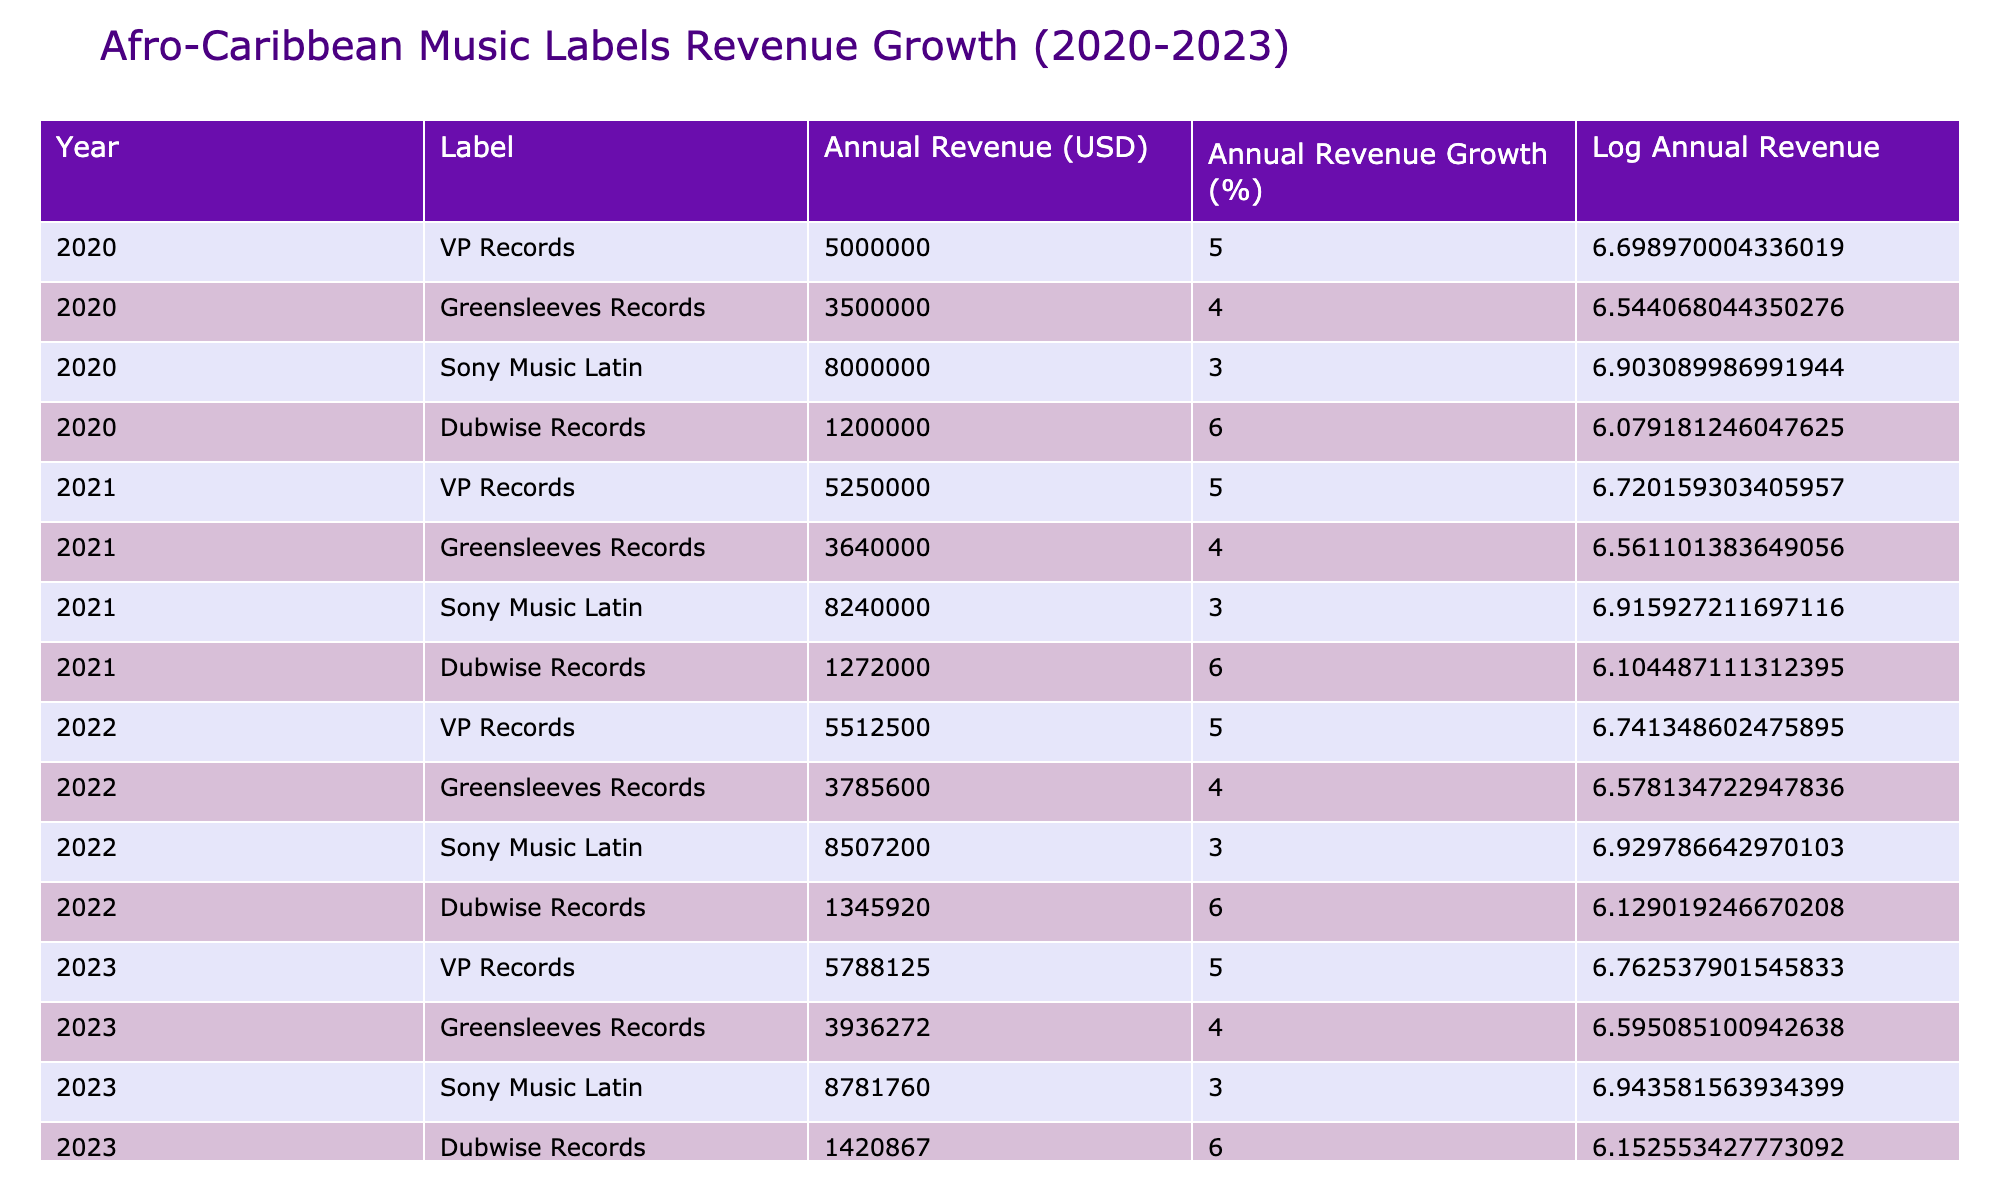What was the annual revenue of Sony Music Latin in 2022? From the table, the annual revenue for Sony Music Latin in 2022 is listed directly under the "Annual Revenue (USD)" column for the year 2022. It shows $8,507,200.
Answer: 8,507,200 Which Afro-Caribbean music label had the highest annual revenue in 2023? By looking at the table for the year 2023, the "Annual Revenue (USD)" values show that Sony Music Latin has the highest revenue of $8,781,760 among the listed labels.
Answer: Sony Music Latin What is the total annual revenue of Dubwise Records from 2020 to 2023? To find the total, we sum the annual revenues for Dubwise Records across all years: 1,200,000 (2020) + 1,272,000 (2021) + 1,345,920 (2022) + 1,420,867 (2023) = $5,238,787.
Answer: 5,238,787 Is the annual revenue growth for Greensleeves Records constant from 2020 to 2023? The table indicates that Greensleeves Records had an annual revenue growth of 4% for each year listed (2020 to 2023). Therefore, the growth is constant.
Answer: Yes Which label had the most significant annual revenue growth percentage in 2021 compared to 2020? The comparison of the growth percentages from 2020 to 2021 shows that Dubwise Records maintained a 6% growth, while other labels had lower percentages. Since Dubwise Records had the same growth percentage from 2021 as it did in 2020 but was the highest two-year growth marker, it retained the highest growth.
Answer: Dubwise Records What was the average annual revenue for VP Records from 2020 to 2023? The revenue values for VP Records across the years are 5,000,000 (2020), 5,250,000 (2021), 5,512,500 (2022), and 5,788,125 (2023). Summing these gives 21,550,625, and dividing by 4 (the number of years) provides an average of $5,387,656.25.
Answer: 5,387,656.25 In 2022, which label had the lowest absolute value in annual revenue growth? From the table, we see that Sony Music Latin had an annual revenue growth of 3% in 2022, which is lower than all other labels' growth percentages in the same year.
Answer: Sony Music Latin What is the difference in annual revenue between VP Records in 2023 and Dubwise Records in 2023? The annual revenue for VP Records in 2023 is 5,788,125 and for Dubwise Records is 1,420,867. The difference is calculated by subtracting: 5,788,125 - 1,420,867 = $4,367,258.
Answer: 4,367,258 